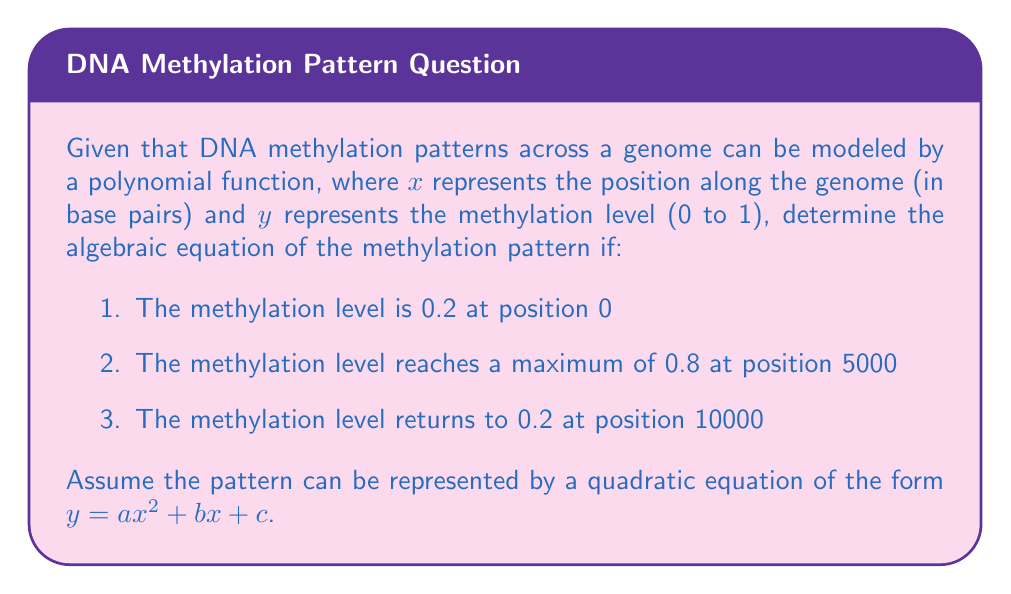Could you help me with this problem? To solve this problem, we'll use the given information to create a system of equations and solve for the coefficients $a$, $b$, and $c$.

Step 1: Set up the equations based on the given information.
1. At $x = 0$, $y = 0.2$: $0.2 = a(0)^2 + b(0) + c$
2. At $x = 5000$, $y = 0.8$: $0.8 = a(5000)^2 + b(5000) + c$
3. At $x = 10000$, $y = 0.2$: $0.2 = a(10000)^2 + b(10000) + c$

Step 2: Simplify the equations.
1. $0.2 = c$
2. $0.8 = 25,000,000a + 5000b + 0.2$
3. $0.2 = 100,000,000a + 10000b + 0.2$

Step 3: Subtract equation 1 from equations 2 and 3.
2. $0.6 = 25,000,000a + 5000b$
3. $0 = 100,000,000a + 10000b$

Step 4: Multiply equation 2 by 2 and subtract from equation 3.
$-1.2 = 50,000,000a$

Step 5: Solve for $a$.
$a = -\frac{1.2}{50,000,000} = -2.4 \times 10^{-8}$

Step 6: Substitute $a$ into equation 2 to solve for $b$.
$0.6 = 25,000,000(-2.4 \times 10^{-8}) + 5000b$
$0.6 = -0.6 + 5000b$
$1.2 = 5000b$
$b = \frac{1.2}{5000} = 2.4 \times 10^{-4}$

Step 7: Recall that $c = 0.2$ from equation 1.

Step 8: Construct the final equation using the calculated values of $a$, $b$, and $c$.
$y = -2.4 \times 10^{-8}x^2 + 2.4 \times 10^{-4}x + 0.2$
Answer: $y = -2.4 \times 10^{-8}x^2 + 2.4 \times 10^{-4}x + 0.2$ 